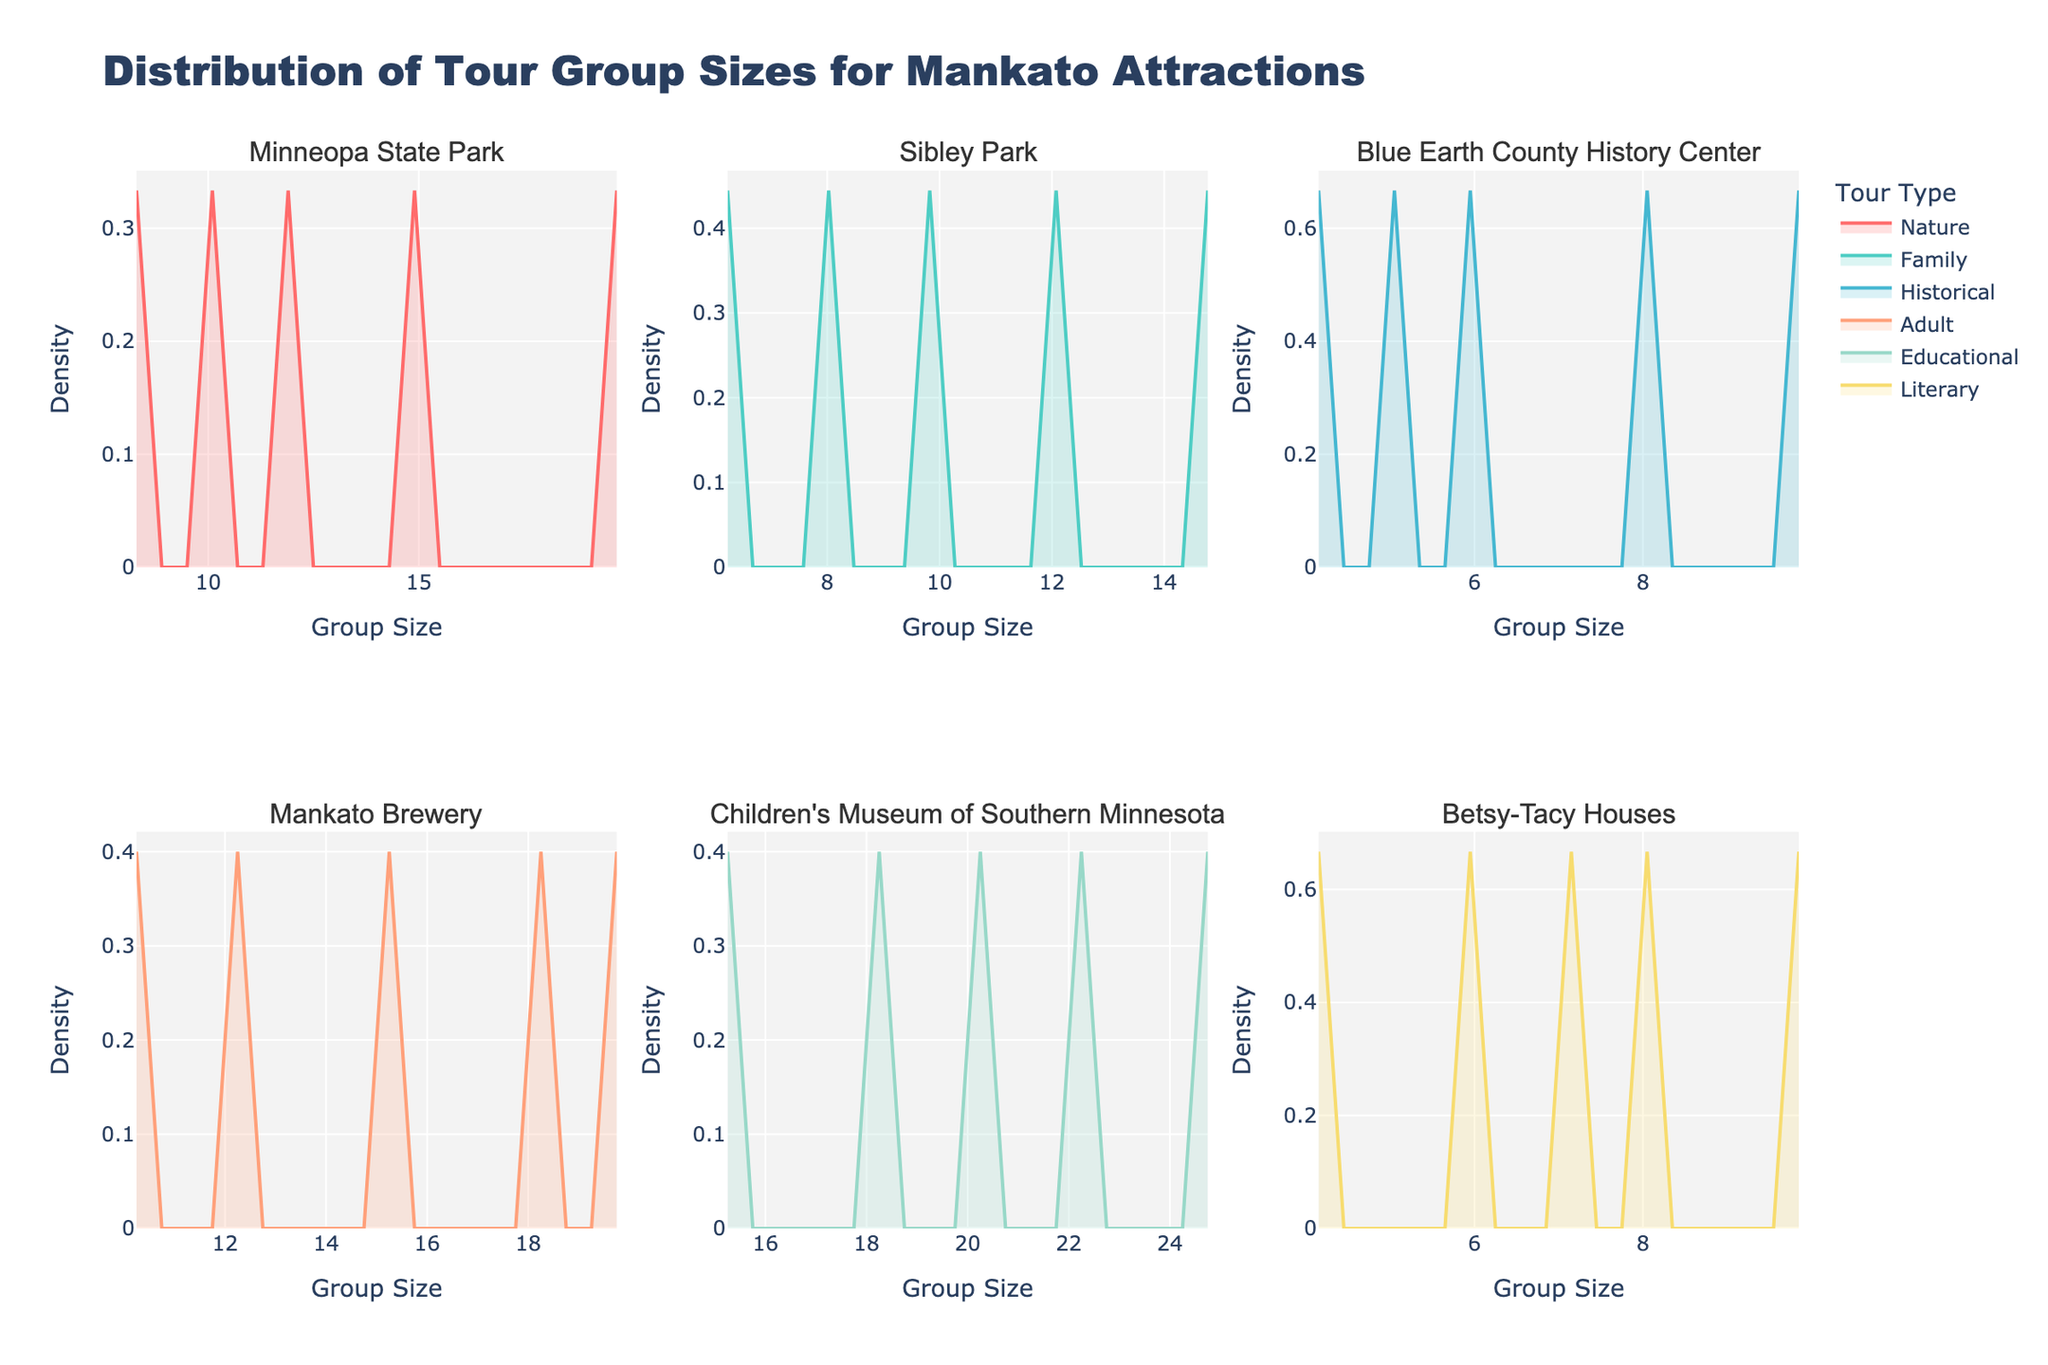What is the title of the figure? Look at the title text positioned at the top of the figure.
Answer: Distribution of Tour Group Sizes for Mankato Attractions How many attractions are displayed in the figure? Count the number of subplot titles, each representing an attraction. There are 6 titles, thus 6 attractions.
Answer: 6 What is the tour type with a color closest to blue in the figure? Identify the colors used for different tour types and find the one closest to blue. It will be labeled in the legend.
Answer: Adult Which axis shows the group sizes? Look for the axis labeled "Group Size" along the bottom or horizontal axis of each subplot.
Answer: X-axis What is the range of group sizes for the Children's Museum of Southern Minnesota? Look at the range of group sizes on the X-axis for the Children's Museum of Southern Minnesota subplot. These range from the lowest to the highest group size indicated.
Answer: 15 to 25 For Minneopa State Park, at what group size does the nature tour type have its highest density? Identify the peak of the density plot for the nature tour type in the Minneopa State Park subplot and note the group size at this peak.
Answer: 12 Which attraction has the highest average group size? Check the density plots of each attraction to see which one has the highest average density for group sizes. The Children's Museum of Southern Minnesota will have the highest average density around higher group sizes.
Answer: Children's Museum of Southern Minnesota Do historical tours have more uniform group sizes between Blue Earth County History Center and Betsy-Tacy Houses? Compare the density plots for historical tour types. In both subplots, check if they are concentrated around certain group sizes or spread out uniformly. Historical tours in Blue Earth County History Center are spread more uniformly across smaller group sizes.
Answer: Blue Earth County History Center For the Mankato Brewery, does any tour type have more than one peak? Examine the density plots for each tour type in the Mankato Brewery subplot to see if any have multiple peaks. Generally, they have a single peak.
Answer: No Which attraction shows the most variation in group sizes for family tours? Compare the spread of the density plots for the family tour type across attractions. The attraction with the widest spread indicates the most variation. Sibley Park shows the most variation.
Answer: Sibley Park 